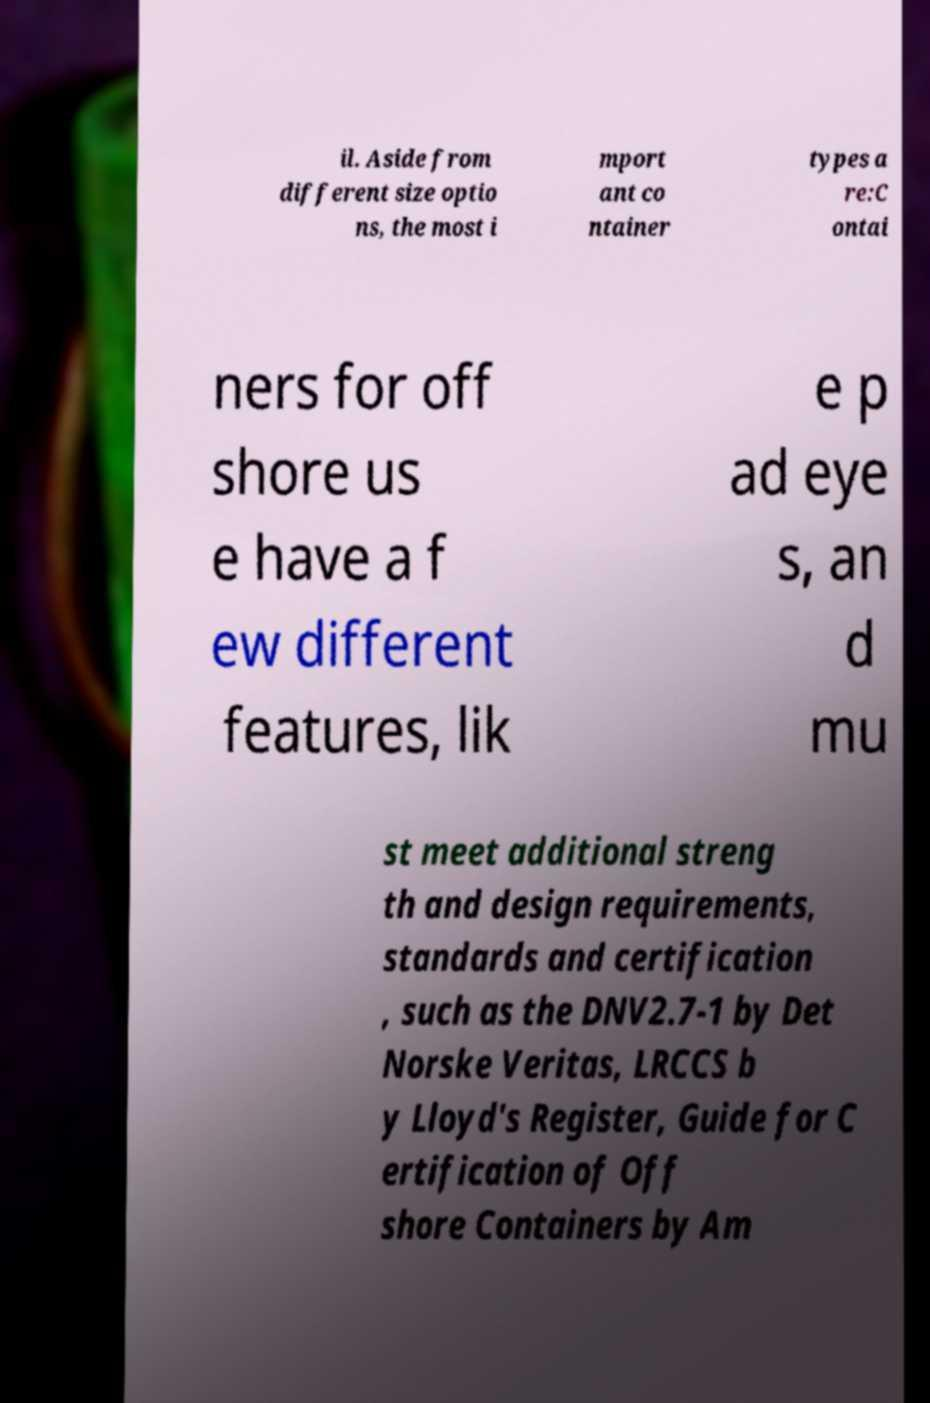Can you read and provide the text displayed in the image?This photo seems to have some interesting text. Can you extract and type it out for me? il. Aside from different size optio ns, the most i mport ant co ntainer types a re:C ontai ners for off shore us e have a f ew different features, lik e p ad eye s, an d mu st meet additional streng th and design requirements, standards and certification , such as the DNV2.7-1 by Det Norske Veritas, LRCCS b y Lloyd's Register, Guide for C ertification of Off shore Containers by Am 